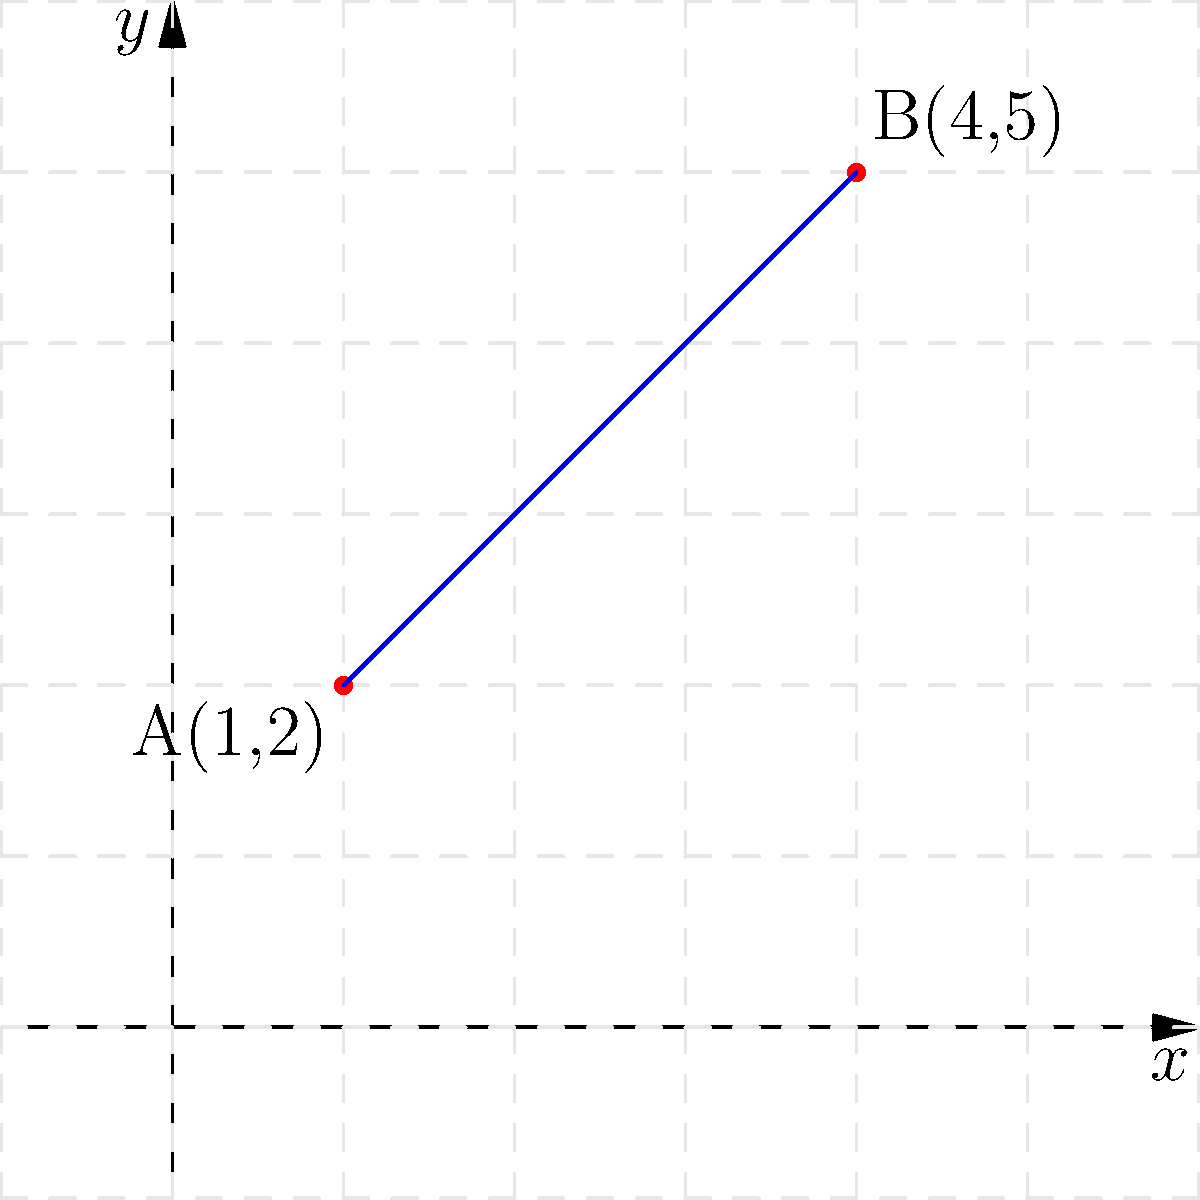Given two points A(1,2) and B(4,5) on a coordinate plane, determine the equation of the line passing through these points. Express your answer in slope-intercept form $(y = mx + b)$. To find the equation of a line passing through two points, we'll use the point-slope form and then convert it to slope-intercept form. Here's the step-by-step process:

1) First, calculate the slope $(m)$ using the slope formula:
   $m = \frac{y_2 - y_1}{x_2 - x_1} = \frac{5 - 2}{4 - 1} = \frac{3}{3} = 1$

2) Now we have the slope, we can use either point to form the point-slope equation. Let's use A(1,2):
   $y - y_1 = m(x - x_1)$
   $y - 2 = 1(x - 1)$

3) Expand the right side:
   $y - 2 = x - 1$

4) Add 2 to both sides to isolate $y$:
   $y = x - 1 + 2$
   $y = x + 1$

5) This is now in slope-intercept form $(y = mx + b)$, where $m = 1$ and $b = 1$.

We can verify this equation satisfies both points:
For A(1,2): $2 = 1(1) + 1$
For B(4,5): $5 = 1(4) + 1$

Both equations are true, confirming our derived equation is correct.
Answer: $y = x + 1$ 